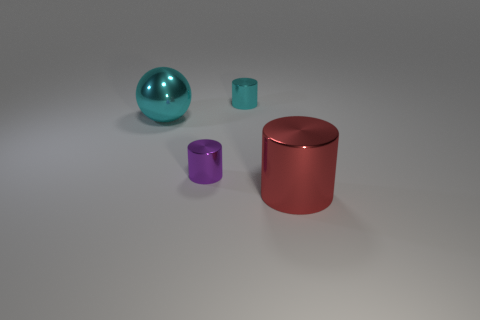Is there anything else that is the same shape as the big cyan thing?
Offer a very short reply. No. There is a big metal thing behind the large cylinder; does it have the same color as the small metallic cylinder that is right of the small purple cylinder?
Provide a short and direct response. Yes. How many things have the same size as the metallic sphere?
Provide a short and direct response. 1. Do the cylinder that is to the right of the cyan cylinder and the large metallic ball have the same size?
Provide a short and direct response. Yes. The small cyan object is what shape?
Keep it short and to the point. Cylinder. Is there a small metal thing of the same color as the metallic ball?
Give a very brief answer. Yes. There is a big object behind the big cylinder; is its shape the same as the large metal object that is in front of the tiny purple shiny cylinder?
Your answer should be compact. No. Is there another cyan ball that has the same material as the big sphere?
Your answer should be compact. No. What number of cyan things are either big metallic cylinders or metallic things?
Offer a very short reply. 2. What size is the object that is behind the tiny purple cylinder and to the right of the large cyan shiny object?
Ensure brevity in your answer.  Small. 